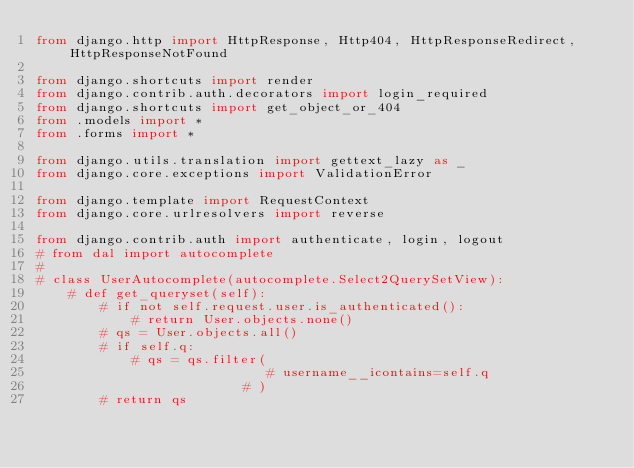<code> <loc_0><loc_0><loc_500><loc_500><_Python_>from django.http import HttpResponse, Http404, HttpResponseRedirect, HttpResponseNotFound

from django.shortcuts import render
from django.contrib.auth.decorators import login_required
from django.shortcuts import get_object_or_404
from .models import *
from .forms import *

from django.utils.translation import gettext_lazy as _
from django.core.exceptions import ValidationError

from django.template import RequestContext
from django.core.urlresolvers import reverse

from django.contrib.auth import authenticate, login, logout
# from dal import autocomplete
#
# class UserAutocomplete(autocomplete.Select2QuerySetView):
    # def get_queryset(self):
        # if not self.request.user.is_authenticated():
            # return User.objects.none()
        # qs = User.objects.all()
        # if self.q:
            # qs = qs.filter(
                             # username__icontains=self.q
                          # )
        # return qs
</code> 